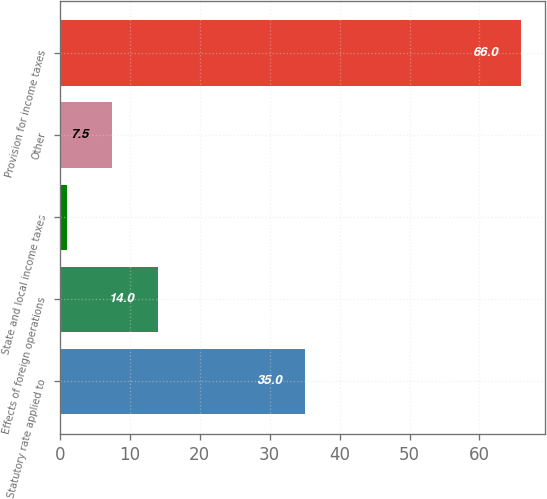Convert chart to OTSL. <chart><loc_0><loc_0><loc_500><loc_500><bar_chart><fcel>Statutory rate applied to<fcel>Effects of foreign operations<fcel>State and local income taxes<fcel>Other<fcel>Provision for income taxes<nl><fcel>35<fcel>14<fcel>1<fcel>7.5<fcel>66<nl></chart> 